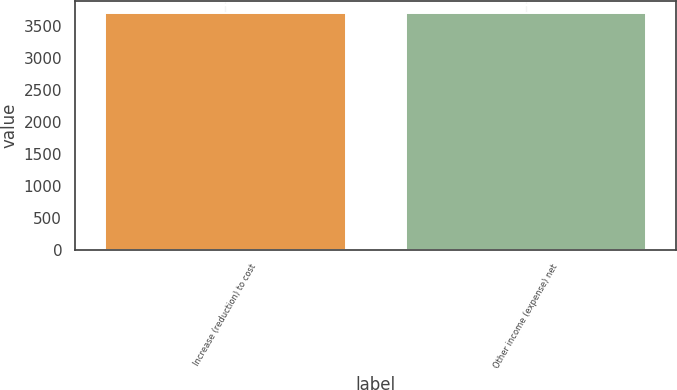Convert chart. <chart><loc_0><loc_0><loc_500><loc_500><bar_chart><fcel>Increase (reduction) to cost<fcel>Other income (expense) net<nl><fcel>3701<fcel>3701.1<nl></chart> 